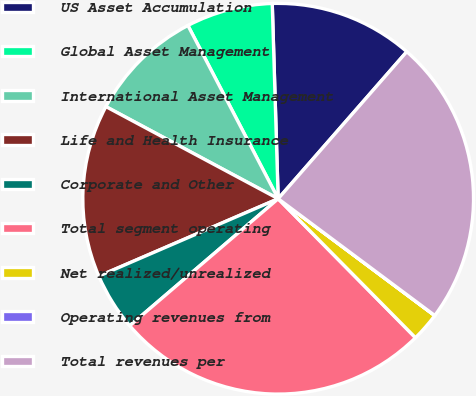Convert chart. <chart><loc_0><loc_0><loc_500><loc_500><pie_chart><fcel>US Asset Accumulation<fcel>Global Asset Management<fcel>International Asset Management<fcel>Life and Health Insurance<fcel>Corporate and Other<fcel>Total segment operating<fcel>Net realized/unrealized<fcel>Operating revenues from<fcel>Total revenues per<nl><fcel>11.92%<fcel>7.16%<fcel>9.54%<fcel>14.3%<fcel>4.78%<fcel>26.14%<fcel>2.39%<fcel>0.01%<fcel>23.76%<nl></chart> 